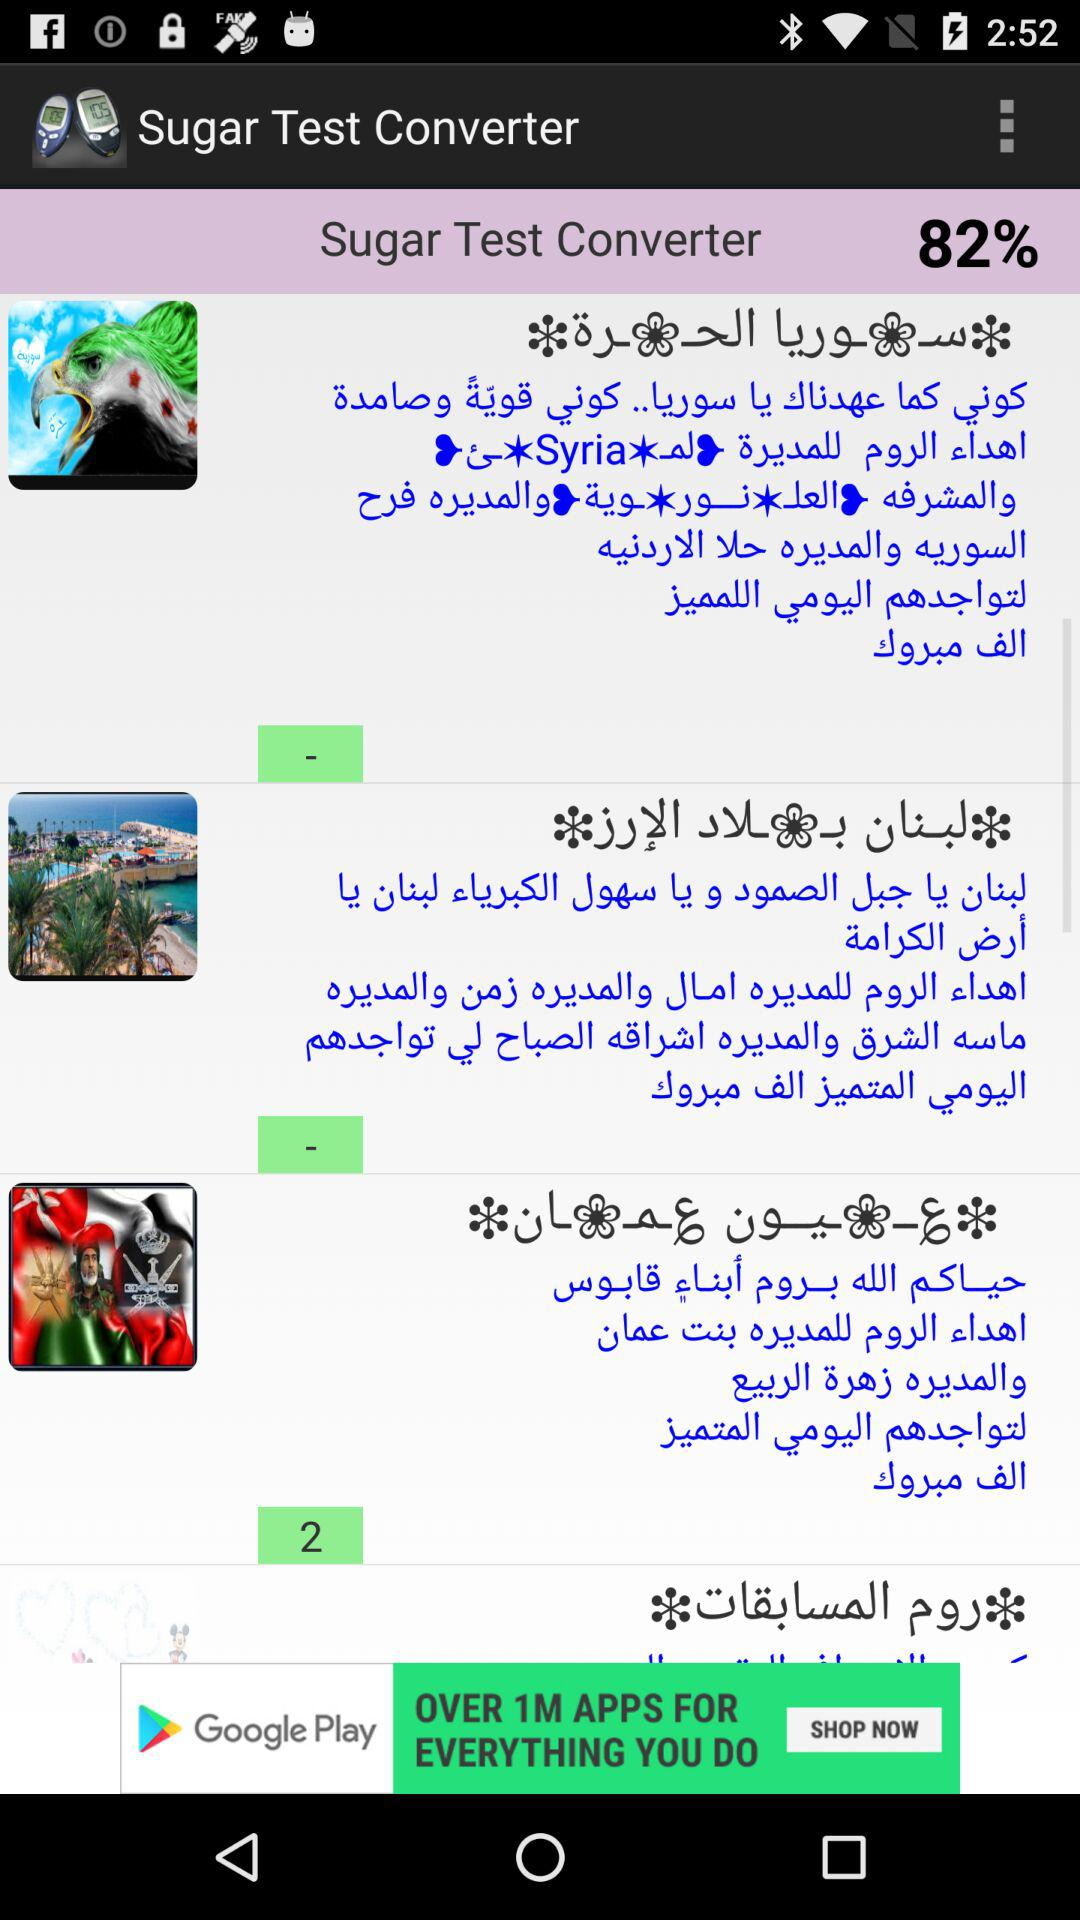How many percent is the highest score?
Answer the question using a single word or phrase. 82% 